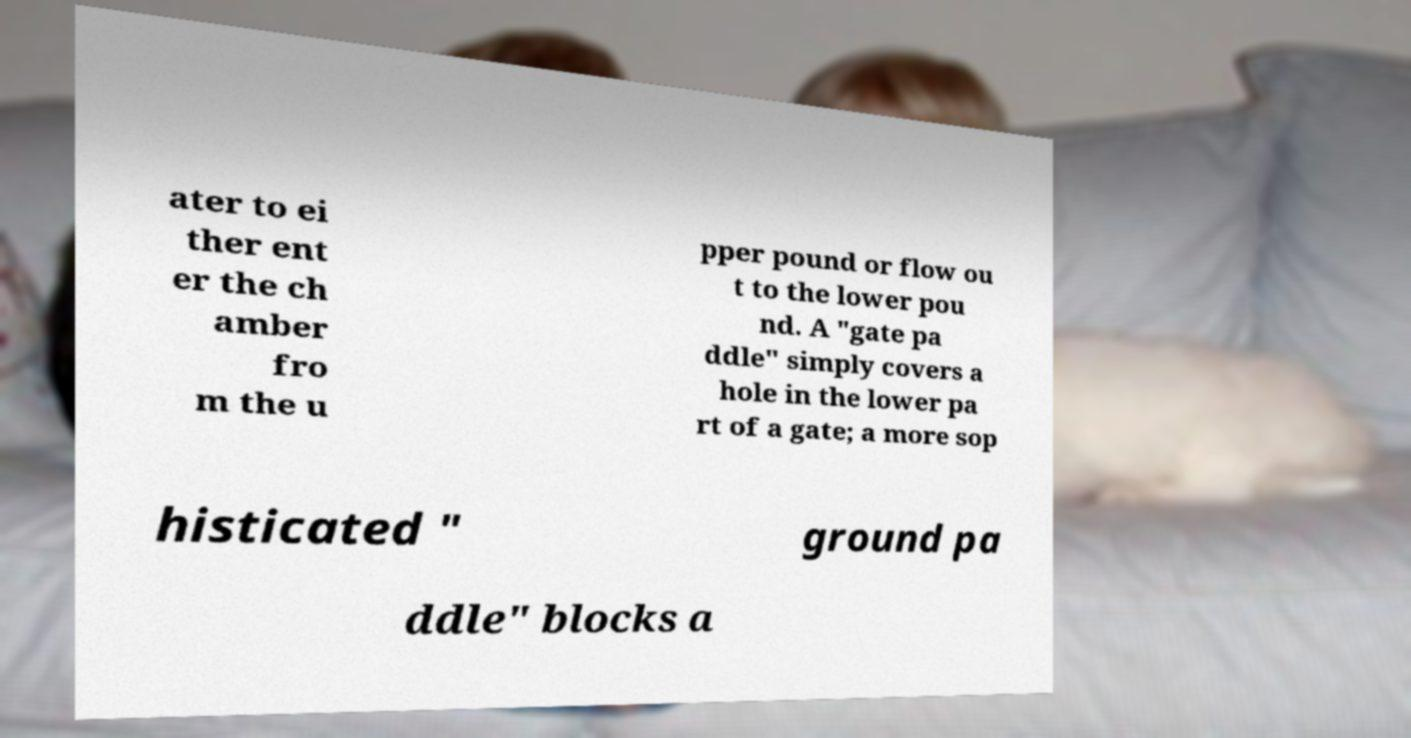For documentation purposes, I need the text within this image transcribed. Could you provide that? ater to ei ther ent er the ch amber fro m the u pper pound or flow ou t to the lower pou nd. A "gate pa ddle" simply covers a hole in the lower pa rt of a gate; a more sop histicated " ground pa ddle" blocks a 